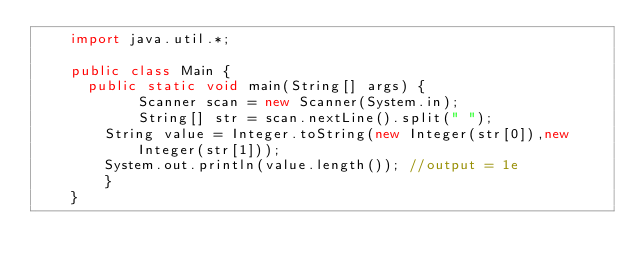<code> <loc_0><loc_0><loc_500><loc_500><_Java_>    import java.util.*;
     
    public class Main {
    	public static void main(String[] args) {
            Scanner scan = new Scanner(System.in);
            String[] str = scan.nextLine().split(" ");
    		String value = Integer.toString(new Integer(str[0]),new Integer(str[1]));
    		System.out.println(value.length()); //output = 1e
        }
    }</code> 